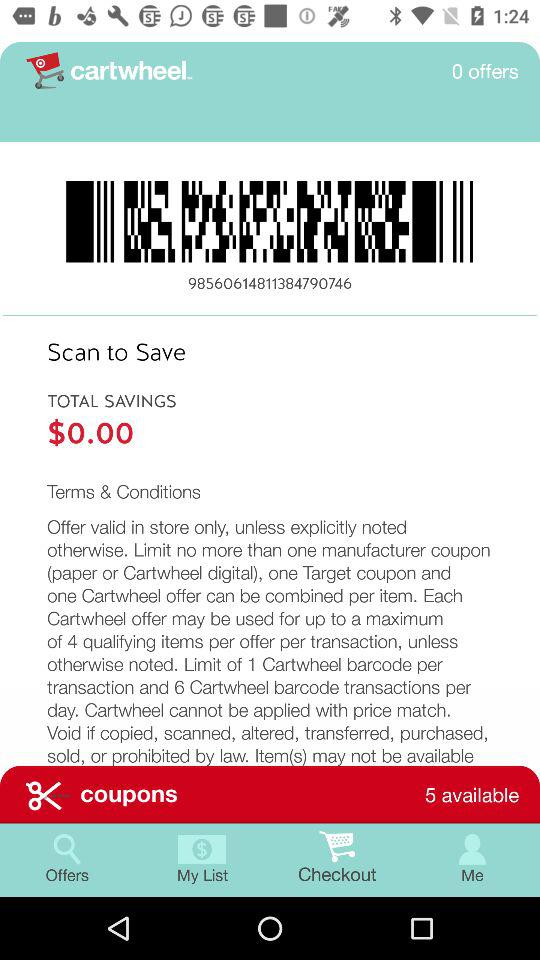How many offers are available? There are 0 offers. 